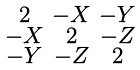<formula> <loc_0><loc_0><loc_500><loc_500>\begin{smallmatrix} 2 & - X & - Y \\ - X & 2 & - Z \\ - Y & - Z & 2 \end{smallmatrix}</formula> 